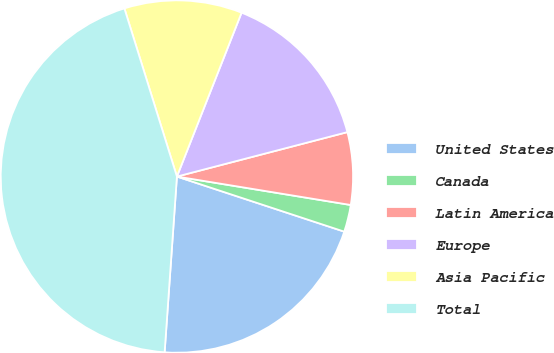Convert chart. <chart><loc_0><loc_0><loc_500><loc_500><pie_chart><fcel>United States<fcel>Canada<fcel>Latin America<fcel>Europe<fcel>Asia Pacific<fcel>Total<nl><fcel>21.05%<fcel>2.48%<fcel>6.64%<fcel>14.96%<fcel>10.8%<fcel>44.07%<nl></chart> 